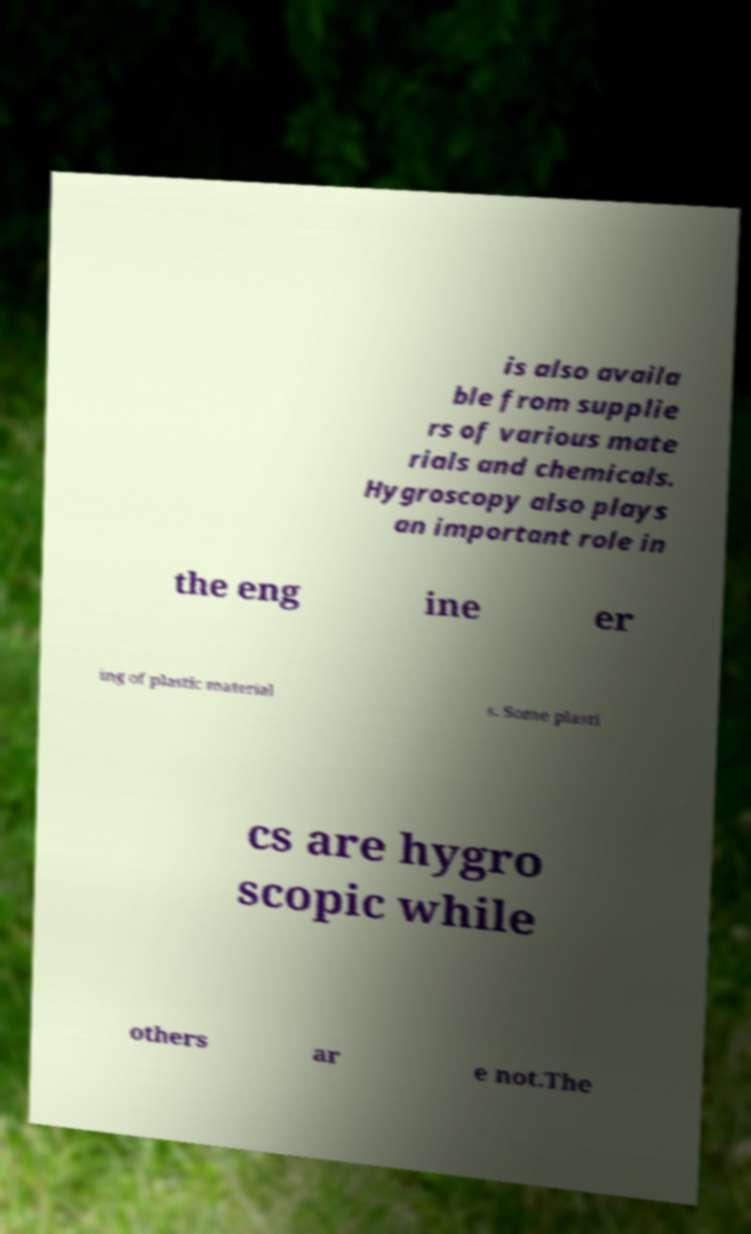Could you assist in decoding the text presented in this image and type it out clearly? is also availa ble from supplie rs of various mate rials and chemicals. Hygroscopy also plays an important role in the eng ine er ing of plastic material s. Some plasti cs are hygro scopic while others ar e not.The 